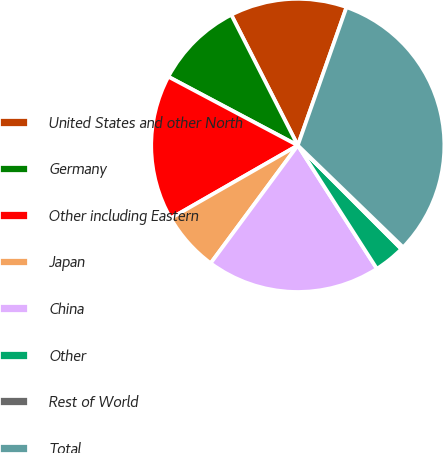<chart> <loc_0><loc_0><loc_500><loc_500><pie_chart><fcel>United States and other North<fcel>Germany<fcel>Other including Eastern<fcel>Japan<fcel>China<fcel>Other<fcel>Rest of World<fcel>Total<nl><fcel>12.89%<fcel>9.74%<fcel>16.05%<fcel>6.58%<fcel>19.21%<fcel>3.42%<fcel>0.27%<fcel>31.84%<nl></chart> 